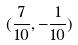<formula> <loc_0><loc_0><loc_500><loc_500>( \frac { 7 } { 1 0 } , - \frac { 1 } { 1 0 } )</formula> 